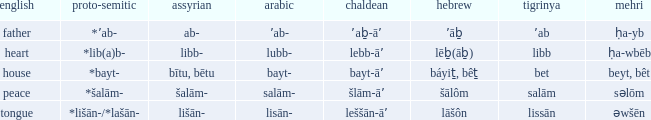If in english it is heart, what is it in hebrew? Lēḇ(āḇ). 